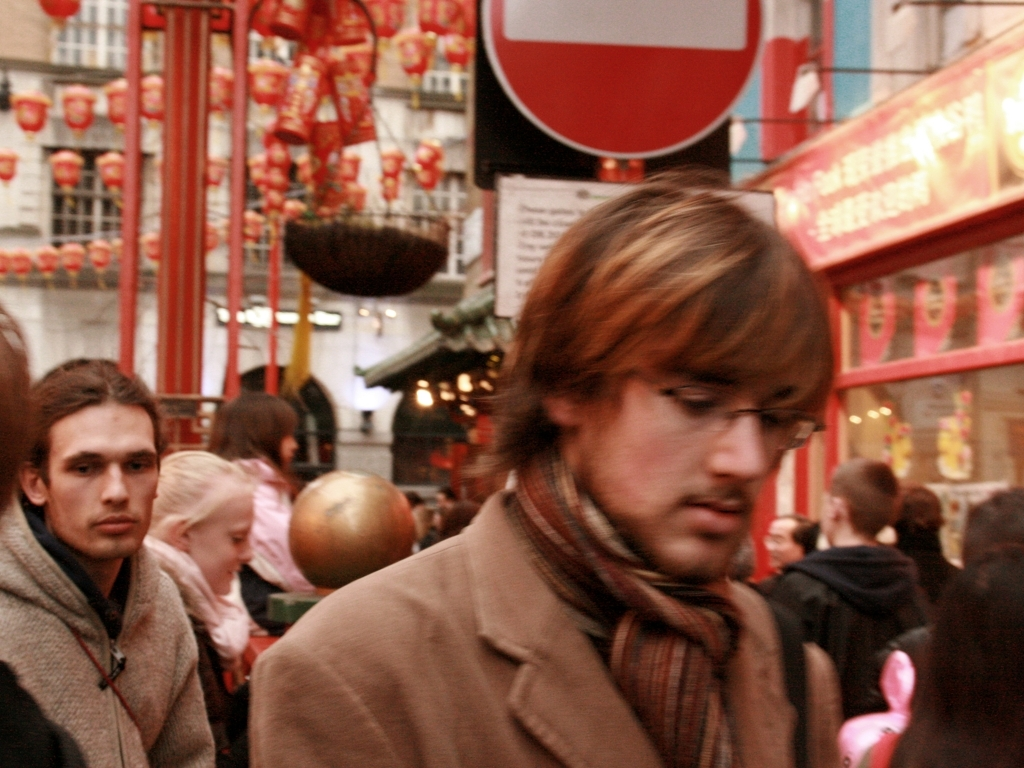Is the color balance appropriate? The color balance appears to be slightly off, with a warm, reddish hue dominating the image. This could be due to the lighting conditions, camera settings, or post-processing technique. The image might benefit from a slight adjustment to the white balance to bring out more natural and neutral colors. 